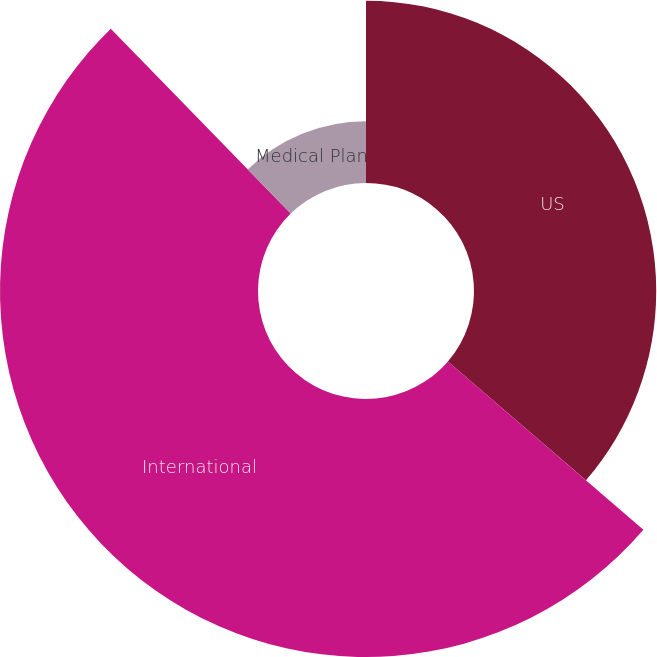Convert chart. <chart><loc_0><loc_0><loc_500><loc_500><pie_chart><fcel>US<fcel>International<fcel>Medical Plan<nl><fcel>36.31%<fcel>51.41%<fcel>12.28%<nl></chart> 